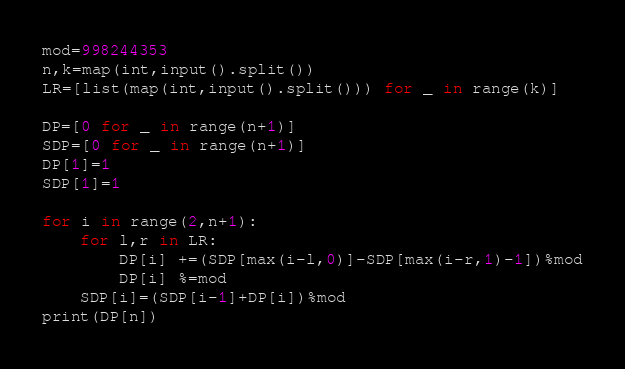Convert code to text. <code><loc_0><loc_0><loc_500><loc_500><_Python_>mod=998244353
n,k=map(int,input().split())
LR=[list(map(int,input().split())) for _ in range(k)]

DP=[0 for _ in range(n+1)]
SDP=[0 for _ in range(n+1)]
DP[1]=1
SDP[1]=1

for i in range(2,n+1):
    for l,r in LR:
        DP[i] +=(SDP[max(i-l,0)]-SDP[max(i-r,1)-1])%mod
        DP[i] %=mod
    SDP[i]=(SDP[i-1]+DP[i])%mod
print(DP[n])</code> 